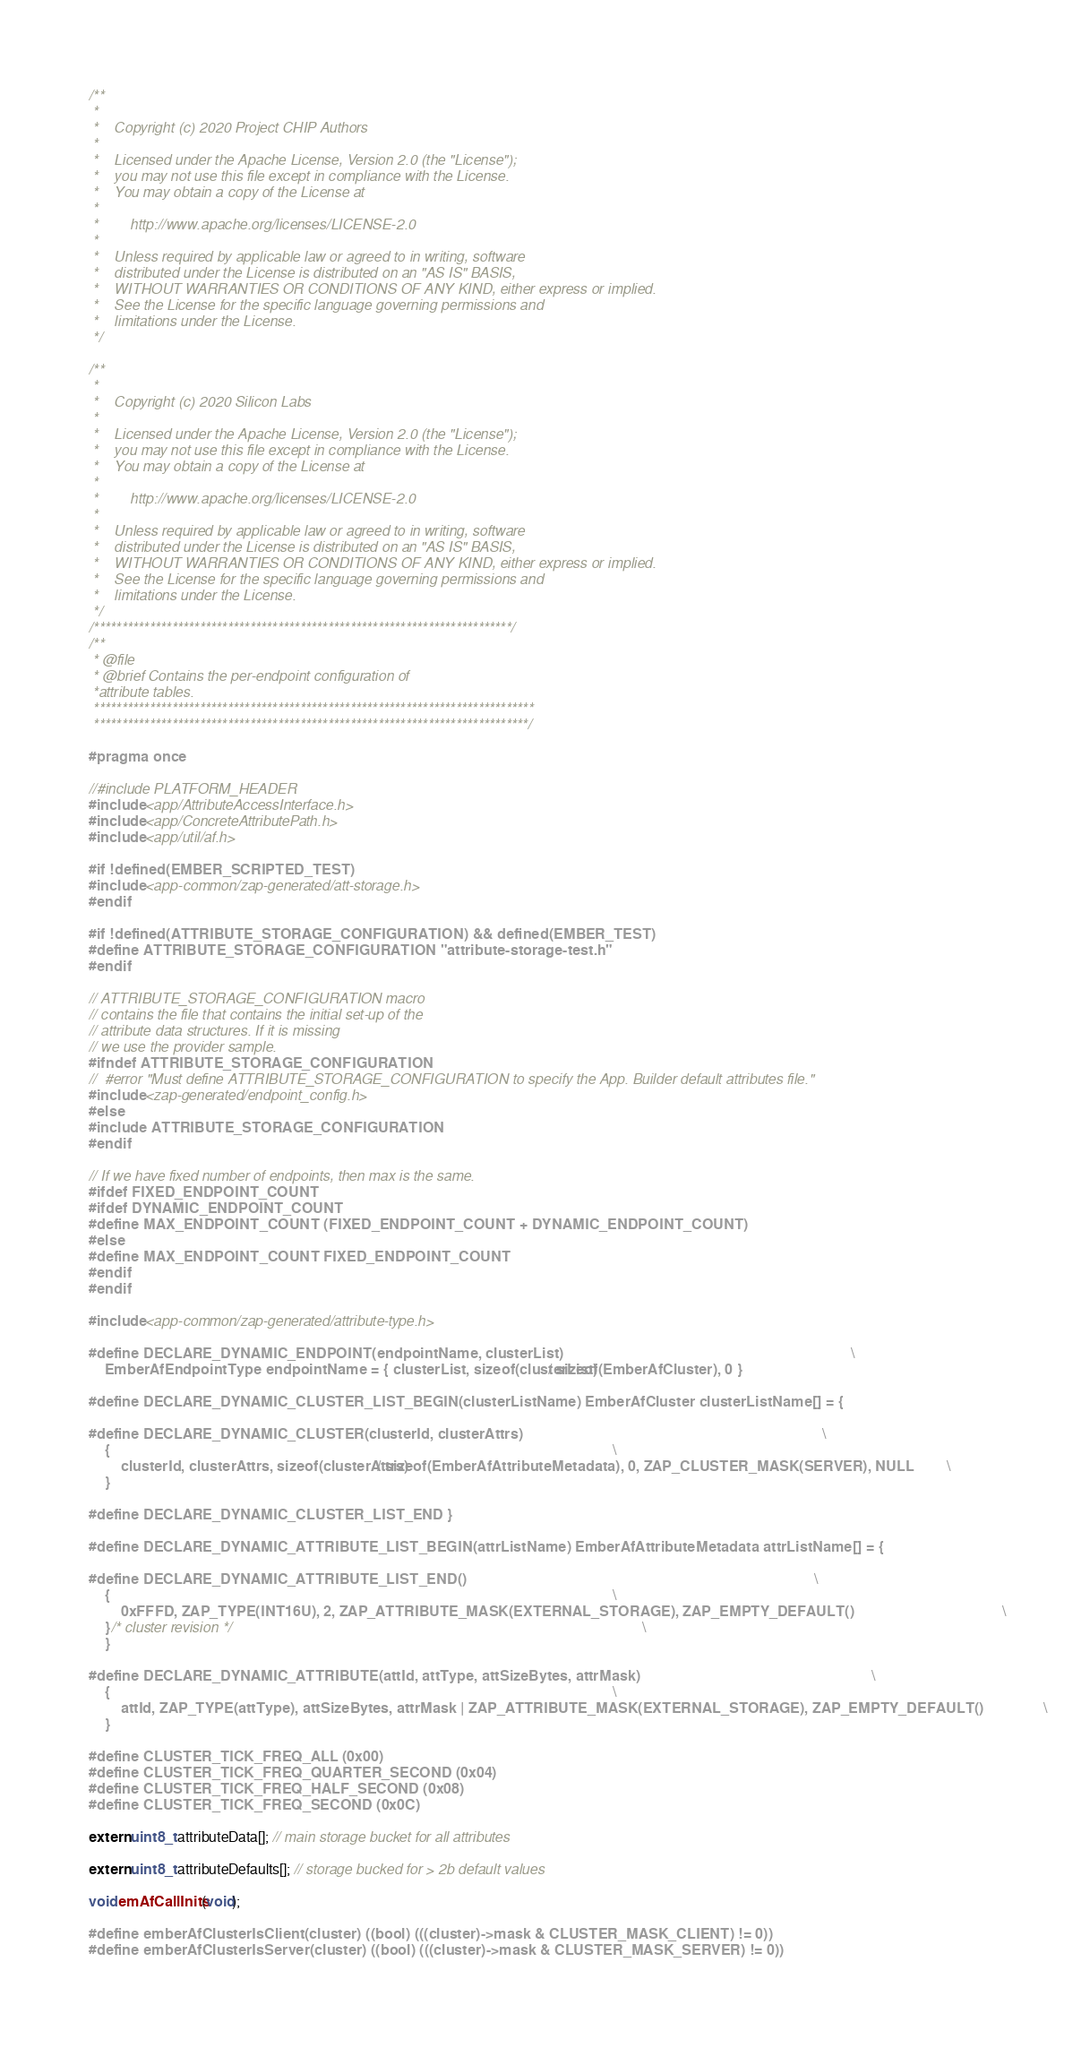<code> <loc_0><loc_0><loc_500><loc_500><_C_>/**
 *
 *    Copyright (c) 2020 Project CHIP Authors
 *
 *    Licensed under the Apache License, Version 2.0 (the "License");
 *    you may not use this file except in compliance with the License.
 *    You may obtain a copy of the License at
 *
 *        http://www.apache.org/licenses/LICENSE-2.0
 *
 *    Unless required by applicable law or agreed to in writing, software
 *    distributed under the License is distributed on an "AS IS" BASIS,
 *    WITHOUT WARRANTIES OR CONDITIONS OF ANY KIND, either express or implied.
 *    See the License for the specific language governing permissions and
 *    limitations under the License.
 */

/**
 *
 *    Copyright (c) 2020 Silicon Labs
 *
 *    Licensed under the Apache License, Version 2.0 (the "License");
 *    you may not use this file except in compliance with the License.
 *    You may obtain a copy of the License at
 *
 *        http://www.apache.org/licenses/LICENSE-2.0
 *
 *    Unless required by applicable law or agreed to in writing, software
 *    distributed under the License is distributed on an "AS IS" BASIS,
 *    WITHOUT WARRANTIES OR CONDITIONS OF ANY KIND, either express or implied.
 *    See the License for the specific language governing permissions and
 *    limitations under the License.
 */
/***************************************************************************/
/**
 * @file
 * @brief Contains the per-endpoint configuration of
 *attribute tables.
 *******************************************************************************
 ******************************************************************************/

#pragma once

//#include PLATFORM_HEADER
#include <app/AttributeAccessInterface.h>
#include <app/ConcreteAttributePath.h>
#include <app/util/af.h>

#if !defined(EMBER_SCRIPTED_TEST)
#include <app-common/zap-generated/att-storage.h>
#endif

#if !defined(ATTRIBUTE_STORAGE_CONFIGURATION) && defined(EMBER_TEST)
#define ATTRIBUTE_STORAGE_CONFIGURATION "attribute-storage-test.h"
#endif

// ATTRIBUTE_STORAGE_CONFIGURATION macro
// contains the file that contains the initial set-up of the
// attribute data structures. If it is missing
// we use the provider sample.
#ifndef ATTRIBUTE_STORAGE_CONFIGURATION
//  #error "Must define ATTRIBUTE_STORAGE_CONFIGURATION to specify the App. Builder default attributes file."
#include <zap-generated/endpoint_config.h>
#else
#include ATTRIBUTE_STORAGE_CONFIGURATION
#endif

// If we have fixed number of endpoints, then max is the same.
#ifdef FIXED_ENDPOINT_COUNT
#ifdef DYNAMIC_ENDPOINT_COUNT
#define MAX_ENDPOINT_COUNT (FIXED_ENDPOINT_COUNT + DYNAMIC_ENDPOINT_COUNT)
#else
#define MAX_ENDPOINT_COUNT FIXED_ENDPOINT_COUNT
#endif
#endif

#include <app-common/zap-generated/attribute-type.h>

#define DECLARE_DYNAMIC_ENDPOINT(endpointName, clusterList)                                                                        \
    EmberAfEndpointType endpointName = { clusterList, sizeof(clusterList) / sizeof(EmberAfCluster), 0 }

#define DECLARE_DYNAMIC_CLUSTER_LIST_BEGIN(clusterListName) EmberAfCluster clusterListName[] = {

#define DECLARE_DYNAMIC_CLUSTER(clusterId, clusterAttrs)                                                                           \
    {                                                                                                                              \
        clusterId, clusterAttrs, sizeof(clusterAttrs) / sizeof(EmberAfAttributeMetadata), 0, ZAP_CLUSTER_MASK(SERVER), NULL        \
    }

#define DECLARE_DYNAMIC_CLUSTER_LIST_END }

#define DECLARE_DYNAMIC_ATTRIBUTE_LIST_BEGIN(attrListName) EmberAfAttributeMetadata attrListName[] = {

#define DECLARE_DYNAMIC_ATTRIBUTE_LIST_END()                                                                                       \
    {                                                                                                                              \
        0xFFFD, ZAP_TYPE(INT16U), 2, ZAP_ATTRIBUTE_MASK(EXTERNAL_STORAGE), ZAP_EMPTY_DEFAULT()                                     \
    } /* cluster revision */                                                                                                       \
    }

#define DECLARE_DYNAMIC_ATTRIBUTE(attId, attType, attSizeBytes, attrMask)                                                          \
    {                                                                                                                              \
        attId, ZAP_TYPE(attType), attSizeBytes, attrMask | ZAP_ATTRIBUTE_MASK(EXTERNAL_STORAGE), ZAP_EMPTY_DEFAULT()               \
    }

#define CLUSTER_TICK_FREQ_ALL (0x00)
#define CLUSTER_TICK_FREQ_QUARTER_SECOND (0x04)
#define CLUSTER_TICK_FREQ_HALF_SECOND (0x08)
#define CLUSTER_TICK_FREQ_SECOND (0x0C)

extern uint8_t attributeData[]; // main storage bucket for all attributes

extern uint8_t attributeDefaults[]; // storage bucked for > 2b default values

void emAfCallInits(void);

#define emberAfClusterIsClient(cluster) ((bool) (((cluster)->mask & CLUSTER_MASK_CLIENT) != 0))
#define emberAfClusterIsServer(cluster) ((bool) (((cluster)->mask & CLUSTER_MASK_SERVER) != 0))</code> 